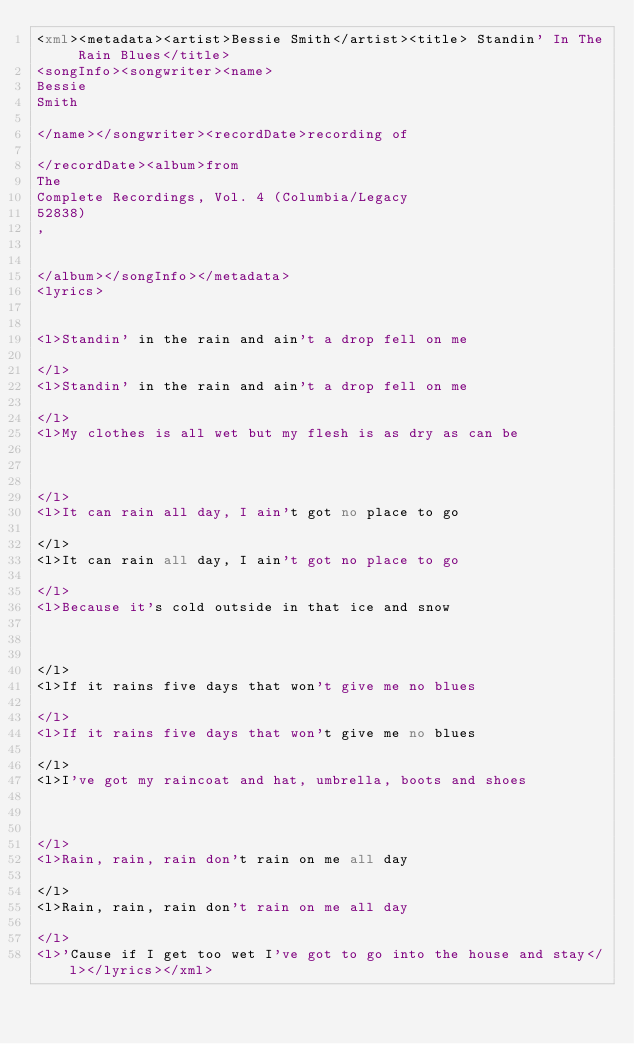<code> <loc_0><loc_0><loc_500><loc_500><_XML_><xml><metadata><artist>Bessie Smith</artist><title> Standin' In The Rain Blues</title>
<songInfo><songwriter><name> 
Bessie
Smith

</name></songwriter><recordDate>recording of

</recordDate><album>from 
The
Complete Recordings, Vol. 4 (Columbia/Legacy
52838)
,


</album></songInfo></metadata>
<lyrics>


<l>Standin' in the rain and ain't a drop fell on me

</l>
<l>Standin' in the rain and ain't a drop fell on me

</l>
<l>My clothes is all wet but my flesh is as dry as can be



</l>
<l>It can rain all day, I ain't got no place to go

</l>
<l>It can rain all day, I ain't got no place to go

</l>
<l>Because it's cold outside in that ice and snow



</l>
<l>If it rains five days that won't give me no blues

</l>
<l>If it rains five days that won't give me no blues

</l>
<l>I've got my raincoat and hat, umbrella, boots and shoes



</l>
<l>Rain, rain, rain don't rain on me all day

</l>
<l>Rain, rain, rain don't rain on me all day

</l>
<l>'Cause if I get too wet I've got to go into the house and stay</l></lyrics></xml>

</code> 